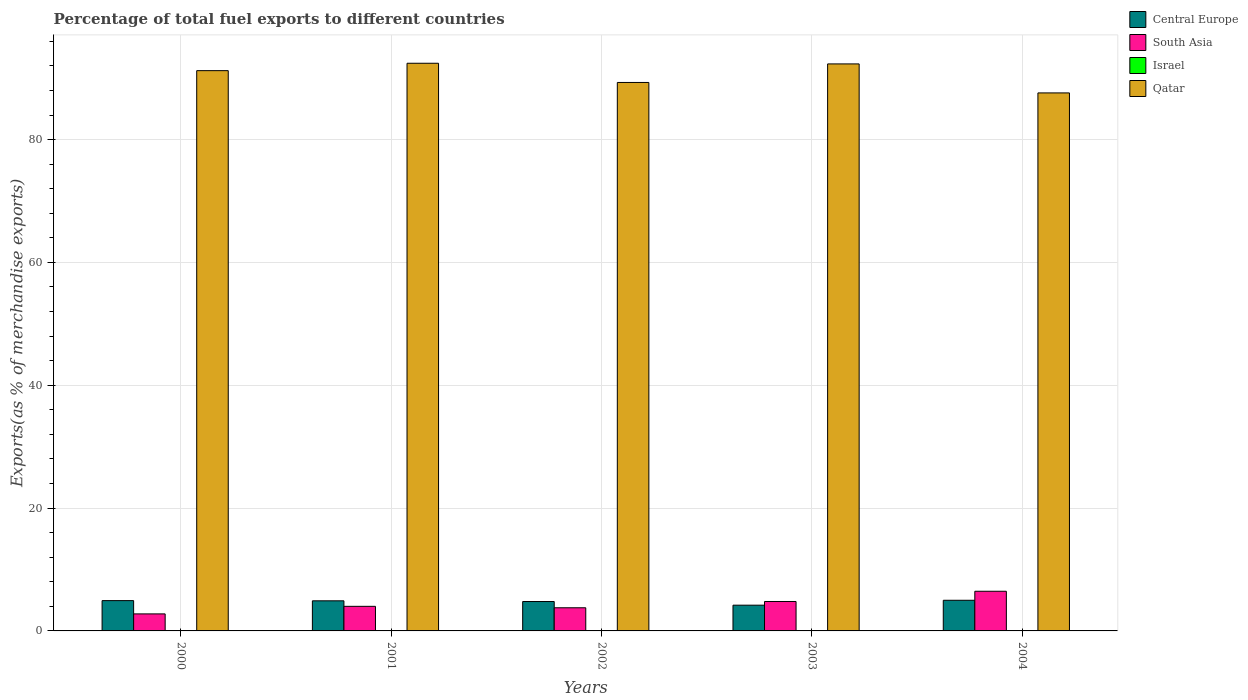How many groups of bars are there?
Your answer should be very brief. 5. How many bars are there on the 4th tick from the left?
Your answer should be very brief. 4. What is the label of the 3rd group of bars from the left?
Provide a succinct answer. 2002. What is the percentage of exports to different countries in South Asia in 2003?
Make the answer very short. 4.79. Across all years, what is the maximum percentage of exports to different countries in South Asia?
Keep it short and to the point. 6.46. Across all years, what is the minimum percentage of exports to different countries in Central Europe?
Your answer should be compact. 4.19. In which year was the percentage of exports to different countries in Qatar minimum?
Ensure brevity in your answer.  2004. What is the total percentage of exports to different countries in Central Europe in the graph?
Make the answer very short. 23.8. What is the difference between the percentage of exports to different countries in Israel in 2001 and that in 2004?
Provide a short and direct response. -0. What is the difference between the percentage of exports to different countries in South Asia in 2003 and the percentage of exports to different countries in Israel in 2002?
Provide a succinct answer. 4.75. What is the average percentage of exports to different countries in South Asia per year?
Your response must be concise. 4.36. In the year 2003, what is the difference between the percentage of exports to different countries in South Asia and percentage of exports to different countries in Central Europe?
Offer a very short reply. 0.6. What is the ratio of the percentage of exports to different countries in Central Europe in 2001 to that in 2003?
Give a very brief answer. 1.17. Is the percentage of exports to different countries in Central Europe in 2002 less than that in 2003?
Give a very brief answer. No. What is the difference between the highest and the second highest percentage of exports to different countries in South Asia?
Keep it short and to the point. 1.67. What is the difference between the highest and the lowest percentage of exports to different countries in Qatar?
Your answer should be very brief. 4.83. What does the 2nd bar from the right in 2003 represents?
Your answer should be compact. Israel. How many bars are there?
Provide a succinct answer. 20. How many years are there in the graph?
Offer a very short reply. 5. How are the legend labels stacked?
Provide a succinct answer. Vertical. What is the title of the graph?
Make the answer very short. Percentage of total fuel exports to different countries. Does "Latin America(developing only)" appear as one of the legend labels in the graph?
Offer a terse response. No. What is the label or title of the Y-axis?
Your answer should be very brief. Exports(as % of merchandise exports). What is the Exports(as % of merchandise exports) of Central Europe in 2000?
Your answer should be very brief. 4.93. What is the Exports(as % of merchandise exports) of South Asia in 2000?
Offer a very short reply. 2.77. What is the Exports(as % of merchandise exports) in Israel in 2000?
Provide a succinct answer. 0.02. What is the Exports(as % of merchandise exports) in Qatar in 2000?
Offer a very short reply. 91.23. What is the Exports(as % of merchandise exports) in Central Europe in 2001?
Give a very brief answer. 4.9. What is the Exports(as % of merchandise exports) of South Asia in 2001?
Your answer should be compact. 4. What is the Exports(as % of merchandise exports) in Israel in 2001?
Keep it short and to the point. 0.02. What is the Exports(as % of merchandise exports) of Qatar in 2001?
Give a very brief answer. 92.43. What is the Exports(as % of merchandise exports) of Central Europe in 2002?
Keep it short and to the point. 4.79. What is the Exports(as % of merchandise exports) of South Asia in 2002?
Ensure brevity in your answer.  3.77. What is the Exports(as % of merchandise exports) in Israel in 2002?
Make the answer very short. 0.04. What is the Exports(as % of merchandise exports) of Qatar in 2002?
Your response must be concise. 89.3. What is the Exports(as % of merchandise exports) of Central Europe in 2003?
Your answer should be compact. 4.19. What is the Exports(as % of merchandise exports) of South Asia in 2003?
Make the answer very short. 4.79. What is the Exports(as % of merchandise exports) in Israel in 2003?
Make the answer very short. 0.04. What is the Exports(as % of merchandise exports) of Qatar in 2003?
Your answer should be very brief. 92.32. What is the Exports(as % of merchandise exports) in Central Europe in 2004?
Your response must be concise. 4.99. What is the Exports(as % of merchandise exports) of South Asia in 2004?
Your response must be concise. 6.46. What is the Exports(as % of merchandise exports) in Israel in 2004?
Make the answer very short. 0.03. What is the Exports(as % of merchandise exports) in Qatar in 2004?
Make the answer very short. 87.6. Across all years, what is the maximum Exports(as % of merchandise exports) in Central Europe?
Your response must be concise. 4.99. Across all years, what is the maximum Exports(as % of merchandise exports) in South Asia?
Offer a terse response. 6.46. Across all years, what is the maximum Exports(as % of merchandise exports) in Israel?
Ensure brevity in your answer.  0.04. Across all years, what is the maximum Exports(as % of merchandise exports) in Qatar?
Provide a short and direct response. 92.43. Across all years, what is the minimum Exports(as % of merchandise exports) of Central Europe?
Keep it short and to the point. 4.19. Across all years, what is the minimum Exports(as % of merchandise exports) of South Asia?
Your answer should be compact. 2.77. Across all years, what is the minimum Exports(as % of merchandise exports) in Israel?
Your answer should be compact. 0.02. Across all years, what is the minimum Exports(as % of merchandise exports) of Qatar?
Provide a short and direct response. 87.6. What is the total Exports(as % of merchandise exports) of Central Europe in the graph?
Offer a very short reply. 23.8. What is the total Exports(as % of merchandise exports) in South Asia in the graph?
Your response must be concise. 21.8. What is the total Exports(as % of merchandise exports) in Israel in the graph?
Your response must be concise. 0.15. What is the total Exports(as % of merchandise exports) in Qatar in the graph?
Offer a terse response. 452.89. What is the difference between the Exports(as % of merchandise exports) of Central Europe in 2000 and that in 2001?
Keep it short and to the point. 0.03. What is the difference between the Exports(as % of merchandise exports) in South Asia in 2000 and that in 2001?
Offer a terse response. -1.23. What is the difference between the Exports(as % of merchandise exports) of Israel in 2000 and that in 2001?
Provide a succinct answer. -0. What is the difference between the Exports(as % of merchandise exports) in Qatar in 2000 and that in 2001?
Make the answer very short. -1.2. What is the difference between the Exports(as % of merchandise exports) in Central Europe in 2000 and that in 2002?
Ensure brevity in your answer.  0.15. What is the difference between the Exports(as % of merchandise exports) in South Asia in 2000 and that in 2002?
Provide a short and direct response. -1. What is the difference between the Exports(as % of merchandise exports) of Israel in 2000 and that in 2002?
Your answer should be compact. -0.02. What is the difference between the Exports(as % of merchandise exports) of Qatar in 2000 and that in 2002?
Provide a succinct answer. 1.92. What is the difference between the Exports(as % of merchandise exports) in Central Europe in 2000 and that in 2003?
Give a very brief answer. 0.74. What is the difference between the Exports(as % of merchandise exports) in South Asia in 2000 and that in 2003?
Your response must be concise. -2.02. What is the difference between the Exports(as % of merchandise exports) in Israel in 2000 and that in 2003?
Your response must be concise. -0.01. What is the difference between the Exports(as % of merchandise exports) in Qatar in 2000 and that in 2003?
Your answer should be very brief. -1.1. What is the difference between the Exports(as % of merchandise exports) in Central Europe in 2000 and that in 2004?
Offer a terse response. -0.06. What is the difference between the Exports(as % of merchandise exports) in South Asia in 2000 and that in 2004?
Keep it short and to the point. -3.69. What is the difference between the Exports(as % of merchandise exports) in Israel in 2000 and that in 2004?
Offer a very short reply. -0. What is the difference between the Exports(as % of merchandise exports) in Qatar in 2000 and that in 2004?
Give a very brief answer. 3.62. What is the difference between the Exports(as % of merchandise exports) in Central Europe in 2001 and that in 2002?
Offer a terse response. 0.12. What is the difference between the Exports(as % of merchandise exports) of South Asia in 2001 and that in 2002?
Provide a succinct answer. 0.23. What is the difference between the Exports(as % of merchandise exports) of Israel in 2001 and that in 2002?
Ensure brevity in your answer.  -0.02. What is the difference between the Exports(as % of merchandise exports) of Qatar in 2001 and that in 2002?
Offer a terse response. 3.13. What is the difference between the Exports(as % of merchandise exports) of Central Europe in 2001 and that in 2003?
Give a very brief answer. 0.71. What is the difference between the Exports(as % of merchandise exports) in South Asia in 2001 and that in 2003?
Your answer should be very brief. -0.79. What is the difference between the Exports(as % of merchandise exports) of Israel in 2001 and that in 2003?
Offer a very short reply. -0.01. What is the difference between the Exports(as % of merchandise exports) in Qatar in 2001 and that in 2003?
Offer a very short reply. 0.11. What is the difference between the Exports(as % of merchandise exports) in Central Europe in 2001 and that in 2004?
Your response must be concise. -0.09. What is the difference between the Exports(as % of merchandise exports) of South Asia in 2001 and that in 2004?
Make the answer very short. -2.45. What is the difference between the Exports(as % of merchandise exports) in Israel in 2001 and that in 2004?
Your answer should be very brief. -0. What is the difference between the Exports(as % of merchandise exports) in Qatar in 2001 and that in 2004?
Keep it short and to the point. 4.83. What is the difference between the Exports(as % of merchandise exports) in Central Europe in 2002 and that in 2003?
Offer a terse response. 0.59. What is the difference between the Exports(as % of merchandise exports) in South Asia in 2002 and that in 2003?
Provide a succinct answer. -1.02. What is the difference between the Exports(as % of merchandise exports) of Israel in 2002 and that in 2003?
Offer a terse response. 0. What is the difference between the Exports(as % of merchandise exports) of Qatar in 2002 and that in 2003?
Provide a short and direct response. -3.02. What is the difference between the Exports(as % of merchandise exports) in Central Europe in 2002 and that in 2004?
Make the answer very short. -0.21. What is the difference between the Exports(as % of merchandise exports) of South Asia in 2002 and that in 2004?
Offer a very short reply. -2.69. What is the difference between the Exports(as % of merchandise exports) of Israel in 2002 and that in 2004?
Offer a very short reply. 0.01. What is the difference between the Exports(as % of merchandise exports) of Qatar in 2002 and that in 2004?
Make the answer very short. 1.7. What is the difference between the Exports(as % of merchandise exports) in Central Europe in 2003 and that in 2004?
Offer a very short reply. -0.8. What is the difference between the Exports(as % of merchandise exports) of South Asia in 2003 and that in 2004?
Offer a terse response. -1.67. What is the difference between the Exports(as % of merchandise exports) in Israel in 2003 and that in 2004?
Offer a very short reply. 0.01. What is the difference between the Exports(as % of merchandise exports) in Qatar in 2003 and that in 2004?
Your answer should be compact. 4.72. What is the difference between the Exports(as % of merchandise exports) of Central Europe in 2000 and the Exports(as % of merchandise exports) of South Asia in 2001?
Provide a succinct answer. 0.93. What is the difference between the Exports(as % of merchandise exports) in Central Europe in 2000 and the Exports(as % of merchandise exports) in Israel in 2001?
Give a very brief answer. 4.91. What is the difference between the Exports(as % of merchandise exports) of Central Europe in 2000 and the Exports(as % of merchandise exports) of Qatar in 2001?
Your answer should be very brief. -87.5. What is the difference between the Exports(as % of merchandise exports) of South Asia in 2000 and the Exports(as % of merchandise exports) of Israel in 2001?
Provide a succinct answer. 2.75. What is the difference between the Exports(as % of merchandise exports) in South Asia in 2000 and the Exports(as % of merchandise exports) in Qatar in 2001?
Ensure brevity in your answer.  -89.66. What is the difference between the Exports(as % of merchandise exports) of Israel in 2000 and the Exports(as % of merchandise exports) of Qatar in 2001?
Keep it short and to the point. -92.41. What is the difference between the Exports(as % of merchandise exports) of Central Europe in 2000 and the Exports(as % of merchandise exports) of South Asia in 2002?
Your response must be concise. 1.16. What is the difference between the Exports(as % of merchandise exports) in Central Europe in 2000 and the Exports(as % of merchandise exports) in Israel in 2002?
Make the answer very short. 4.89. What is the difference between the Exports(as % of merchandise exports) in Central Europe in 2000 and the Exports(as % of merchandise exports) in Qatar in 2002?
Your answer should be very brief. -84.37. What is the difference between the Exports(as % of merchandise exports) in South Asia in 2000 and the Exports(as % of merchandise exports) in Israel in 2002?
Give a very brief answer. 2.73. What is the difference between the Exports(as % of merchandise exports) of South Asia in 2000 and the Exports(as % of merchandise exports) of Qatar in 2002?
Ensure brevity in your answer.  -86.53. What is the difference between the Exports(as % of merchandise exports) of Israel in 2000 and the Exports(as % of merchandise exports) of Qatar in 2002?
Ensure brevity in your answer.  -89.28. What is the difference between the Exports(as % of merchandise exports) in Central Europe in 2000 and the Exports(as % of merchandise exports) in South Asia in 2003?
Your response must be concise. 0.14. What is the difference between the Exports(as % of merchandise exports) of Central Europe in 2000 and the Exports(as % of merchandise exports) of Israel in 2003?
Offer a terse response. 4.89. What is the difference between the Exports(as % of merchandise exports) of Central Europe in 2000 and the Exports(as % of merchandise exports) of Qatar in 2003?
Your answer should be very brief. -87.39. What is the difference between the Exports(as % of merchandise exports) in South Asia in 2000 and the Exports(as % of merchandise exports) in Israel in 2003?
Offer a very short reply. 2.73. What is the difference between the Exports(as % of merchandise exports) of South Asia in 2000 and the Exports(as % of merchandise exports) of Qatar in 2003?
Offer a terse response. -89.55. What is the difference between the Exports(as % of merchandise exports) of Israel in 2000 and the Exports(as % of merchandise exports) of Qatar in 2003?
Provide a short and direct response. -92.3. What is the difference between the Exports(as % of merchandise exports) of Central Europe in 2000 and the Exports(as % of merchandise exports) of South Asia in 2004?
Ensure brevity in your answer.  -1.52. What is the difference between the Exports(as % of merchandise exports) in Central Europe in 2000 and the Exports(as % of merchandise exports) in Israel in 2004?
Keep it short and to the point. 4.91. What is the difference between the Exports(as % of merchandise exports) of Central Europe in 2000 and the Exports(as % of merchandise exports) of Qatar in 2004?
Your response must be concise. -82.67. What is the difference between the Exports(as % of merchandise exports) in South Asia in 2000 and the Exports(as % of merchandise exports) in Israel in 2004?
Your answer should be compact. 2.75. What is the difference between the Exports(as % of merchandise exports) of South Asia in 2000 and the Exports(as % of merchandise exports) of Qatar in 2004?
Ensure brevity in your answer.  -84.83. What is the difference between the Exports(as % of merchandise exports) in Israel in 2000 and the Exports(as % of merchandise exports) in Qatar in 2004?
Your answer should be compact. -87.58. What is the difference between the Exports(as % of merchandise exports) of Central Europe in 2001 and the Exports(as % of merchandise exports) of South Asia in 2002?
Offer a terse response. 1.13. What is the difference between the Exports(as % of merchandise exports) in Central Europe in 2001 and the Exports(as % of merchandise exports) in Israel in 2002?
Your response must be concise. 4.86. What is the difference between the Exports(as % of merchandise exports) in Central Europe in 2001 and the Exports(as % of merchandise exports) in Qatar in 2002?
Your response must be concise. -84.4. What is the difference between the Exports(as % of merchandise exports) of South Asia in 2001 and the Exports(as % of merchandise exports) of Israel in 2002?
Your answer should be compact. 3.96. What is the difference between the Exports(as % of merchandise exports) of South Asia in 2001 and the Exports(as % of merchandise exports) of Qatar in 2002?
Keep it short and to the point. -85.3. What is the difference between the Exports(as % of merchandise exports) of Israel in 2001 and the Exports(as % of merchandise exports) of Qatar in 2002?
Keep it short and to the point. -89.28. What is the difference between the Exports(as % of merchandise exports) of Central Europe in 2001 and the Exports(as % of merchandise exports) of South Asia in 2003?
Your response must be concise. 0.11. What is the difference between the Exports(as % of merchandise exports) of Central Europe in 2001 and the Exports(as % of merchandise exports) of Israel in 2003?
Your answer should be very brief. 4.86. What is the difference between the Exports(as % of merchandise exports) in Central Europe in 2001 and the Exports(as % of merchandise exports) in Qatar in 2003?
Your answer should be very brief. -87.42. What is the difference between the Exports(as % of merchandise exports) in South Asia in 2001 and the Exports(as % of merchandise exports) in Israel in 2003?
Your response must be concise. 3.97. What is the difference between the Exports(as % of merchandise exports) of South Asia in 2001 and the Exports(as % of merchandise exports) of Qatar in 2003?
Provide a succinct answer. -88.32. What is the difference between the Exports(as % of merchandise exports) in Israel in 2001 and the Exports(as % of merchandise exports) in Qatar in 2003?
Your answer should be compact. -92.3. What is the difference between the Exports(as % of merchandise exports) in Central Europe in 2001 and the Exports(as % of merchandise exports) in South Asia in 2004?
Give a very brief answer. -1.56. What is the difference between the Exports(as % of merchandise exports) in Central Europe in 2001 and the Exports(as % of merchandise exports) in Israel in 2004?
Your answer should be very brief. 4.87. What is the difference between the Exports(as % of merchandise exports) in Central Europe in 2001 and the Exports(as % of merchandise exports) in Qatar in 2004?
Ensure brevity in your answer.  -82.7. What is the difference between the Exports(as % of merchandise exports) of South Asia in 2001 and the Exports(as % of merchandise exports) of Israel in 2004?
Offer a terse response. 3.98. What is the difference between the Exports(as % of merchandise exports) of South Asia in 2001 and the Exports(as % of merchandise exports) of Qatar in 2004?
Provide a short and direct response. -83.6. What is the difference between the Exports(as % of merchandise exports) in Israel in 2001 and the Exports(as % of merchandise exports) in Qatar in 2004?
Ensure brevity in your answer.  -87.58. What is the difference between the Exports(as % of merchandise exports) of Central Europe in 2002 and the Exports(as % of merchandise exports) of South Asia in 2003?
Ensure brevity in your answer.  -0.01. What is the difference between the Exports(as % of merchandise exports) of Central Europe in 2002 and the Exports(as % of merchandise exports) of Israel in 2003?
Your answer should be very brief. 4.75. What is the difference between the Exports(as % of merchandise exports) of Central Europe in 2002 and the Exports(as % of merchandise exports) of Qatar in 2003?
Your response must be concise. -87.54. What is the difference between the Exports(as % of merchandise exports) of South Asia in 2002 and the Exports(as % of merchandise exports) of Israel in 2003?
Your answer should be compact. 3.73. What is the difference between the Exports(as % of merchandise exports) of South Asia in 2002 and the Exports(as % of merchandise exports) of Qatar in 2003?
Provide a succinct answer. -88.56. What is the difference between the Exports(as % of merchandise exports) in Israel in 2002 and the Exports(as % of merchandise exports) in Qatar in 2003?
Provide a short and direct response. -92.28. What is the difference between the Exports(as % of merchandise exports) of Central Europe in 2002 and the Exports(as % of merchandise exports) of South Asia in 2004?
Keep it short and to the point. -1.67. What is the difference between the Exports(as % of merchandise exports) in Central Europe in 2002 and the Exports(as % of merchandise exports) in Israel in 2004?
Offer a terse response. 4.76. What is the difference between the Exports(as % of merchandise exports) in Central Europe in 2002 and the Exports(as % of merchandise exports) in Qatar in 2004?
Offer a terse response. -82.82. What is the difference between the Exports(as % of merchandise exports) of South Asia in 2002 and the Exports(as % of merchandise exports) of Israel in 2004?
Provide a succinct answer. 3.74. What is the difference between the Exports(as % of merchandise exports) in South Asia in 2002 and the Exports(as % of merchandise exports) in Qatar in 2004?
Your response must be concise. -83.83. What is the difference between the Exports(as % of merchandise exports) in Israel in 2002 and the Exports(as % of merchandise exports) in Qatar in 2004?
Your answer should be compact. -87.56. What is the difference between the Exports(as % of merchandise exports) in Central Europe in 2003 and the Exports(as % of merchandise exports) in South Asia in 2004?
Offer a very short reply. -2.27. What is the difference between the Exports(as % of merchandise exports) in Central Europe in 2003 and the Exports(as % of merchandise exports) in Israel in 2004?
Your response must be concise. 4.16. What is the difference between the Exports(as % of merchandise exports) of Central Europe in 2003 and the Exports(as % of merchandise exports) of Qatar in 2004?
Provide a short and direct response. -83.41. What is the difference between the Exports(as % of merchandise exports) in South Asia in 2003 and the Exports(as % of merchandise exports) in Israel in 2004?
Your answer should be very brief. 4.76. What is the difference between the Exports(as % of merchandise exports) of South Asia in 2003 and the Exports(as % of merchandise exports) of Qatar in 2004?
Provide a short and direct response. -82.81. What is the difference between the Exports(as % of merchandise exports) in Israel in 2003 and the Exports(as % of merchandise exports) in Qatar in 2004?
Provide a succinct answer. -87.56. What is the average Exports(as % of merchandise exports) of Central Europe per year?
Give a very brief answer. 4.76. What is the average Exports(as % of merchandise exports) in South Asia per year?
Provide a short and direct response. 4.36. What is the average Exports(as % of merchandise exports) of Israel per year?
Give a very brief answer. 0.03. What is the average Exports(as % of merchandise exports) of Qatar per year?
Offer a very short reply. 90.58. In the year 2000, what is the difference between the Exports(as % of merchandise exports) in Central Europe and Exports(as % of merchandise exports) in South Asia?
Your answer should be very brief. 2.16. In the year 2000, what is the difference between the Exports(as % of merchandise exports) of Central Europe and Exports(as % of merchandise exports) of Israel?
Ensure brevity in your answer.  4.91. In the year 2000, what is the difference between the Exports(as % of merchandise exports) of Central Europe and Exports(as % of merchandise exports) of Qatar?
Make the answer very short. -86.29. In the year 2000, what is the difference between the Exports(as % of merchandise exports) in South Asia and Exports(as % of merchandise exports) in Israel?
Offer a terse response. 2.75. In the year 2000, what is the difference between the Exports(as % of merchandise exports) in South Asia and Exports(as % of merchandise exports) in Qatar?
Ensure brevity in your answer.  -88.45. In the year 2000, what is the difference between the Exports(as % of merchandise exports) in Israel and Exports(as % of merchandise exports) in Qatar?
Provide a succinct answer. -91.2. In the year 2001, what is the difference between the Exports(as % of merchandise exports) of Central Europe and Exports(as % of merchandise exports) of South Asia?
Offer a terse response. 0.9. In the year 2001, what is the difference between the Exports(as % of merchandise exports) in Central Europe and Exports(as % of merchandise exports) in Israel?
Your answer should be compact. 4.88. In the year 2001, what is the difference between the Exports(as % of merchandise exports) in Central Europe and Exports(as % of merchandise exports) in Qatar?
Offer a very short reply. -87.53. In the year 2001, what is the difference between the Exports(as % of merchandise exports) of South Asia and Exports(as % of merchandise exports) of Israel?
Make the answer very short. 3.98. In the year 2001, what is the difference between the Exports(as % of merchandise exports) in South Asia and Exports(as % of merchandise exports) in Qatar?
Ensure brevity in your answer.  -88.43. In the year 2001, what is the difference between the Exports(as % of merchandise exports) in Israel and Exports(as % of merchandise exports) in Qatar?
Your answer should be compact. -92.41. In the year 2002, what is the difference between the Exports(as % of merchandise exports) of Central Europe and Exports(as % of merchandise exports) of South Asia?
Offer a very short reply. 1.02. In the year 2002, what is the difference between the Exports(as % of merchandise exports) of Central Europe and Exports(as % of merchandise exports) of Israel?
Your answer should be compact. 4.75. In the year 2002, what is the difference between the Exports(as % of merchandise exports) in Central Europe and Exports(as % of merchandise exports) in Qatar?
Your response must be concise. -84.52. In the year 2002, what is the difference between the Exports(as % of merchandise exports) in South Asia and Exports(as % of merchandise exports) in Israel?
Your answer should be very brief. 3.73. In the year 2002, what is the difference between the Exports(as % of merchandise exports) of South Asia and Exports(as % of merchandise exports) of Qatar?
Keep it short and to the point. -85.54. In the year 2002, what is the difference between the Exports(as % of merchandise exports) of Israel and Exports(as % of merchandise exports) of Qatar?
Provide a short and direct response. -89.26. In the year 2003, what is the difference between the Exports(as % of merchandise exports) of Central Europe and Exports(as % of merchandise exports) of South Asia?
Your answer should be compact. -0.6. In the year 2003, what is the difference between the Exports(as % of merchandise exports) in Central Europe and Exports(as % of merchandise exports) in Israel?
Give a very brief answer. 4.15. In the year 2003, what is the difference between the Exports(as % of merchandise exports) in Central Europe and Exports(as % of merchandise exports) in Qatar?
Keep it short and to the point. -88.13. In the year 2003, what is the difference between the Exports(as % of merchandise exports) in South Asia and Exports(as % of merchandise exports) in Israel?
Provide a short and direct response. 4.75. In the year 2003, what is the difference between the Exports(as % of merchandise exports) of South Asia and Exports(as % of merchandise exports) of Qatar?
Your answer should be compact. -87.53. In the year 2003, what is the difference between the Exports(as % of merchandise exports) of Israel and Exports(as % of merchandise exports) of Qatar?
Offer a terse response. -92.29. In the year 2004, what is the difference between the Exports(as % of merchandise exports) in Central Europe and Exports(as % of merchandise exports) in South Asia?
Ensure brevity in your answer.  -1.47. In the year 2004, what is the difference between the Exports(as % of merchandise exports) in Central Europe and Exports(as % of merchandise exports) in Israel?
Make the answer very short. 4.96. In the year 2004, what is the difference between the Exports(as % of merchandise exports) in Central Europe and Exports(as % of merchandise exports) in Qatar?
Keep it short and to the point. -82.61. In the year 2004, what is the difference between the Exports(as % of merchandise exports) in South Asia and Exports(as % of merchandise exports) in Israel?
Offer a very short reply. 6.43. In the year 2004, what is the difference between the Exports(as % of merchandise exports) in South Asia and Exports(as % of merchandise exports) in Qatar?
Provide a succinct answer. -81.15. In the year 2004, what is the difference between the Exports(as % of merchandise exports) of Israel and Exports(as % of merchandise exports) of Qatar?
Give a very brief answer. -87.58. What is the ratio of the Exports(as % of merchandise exports) in South Asia in 2000 to that in 2001?
Keep it short and to the point. 0.69. What is the ratio of the Exports(as % of merchandise exports) of Israel in 2000 to that in 2001?
Keep it short and to the point. 0.98. What is the ratio of the Exports(as % of merchandise exports) in Qatar in 2000 to that in 2001?
Keep it short and to the point. 0.99. What is the ratio of the Exports(as % of merchandise exports) in Central Europe in 2000 to that in 2002?
Make the answer very short. 1.03. What is the ratio of the Exports(as % of merchandise exports) of South Asia in 2000 to that in 2002?
Ensure brevity in your answer.  0.74. What is the ratio of the Exports(as % of merchandise exports) of Israel in 2000 to that in 2002?
Your response must be concise. 0.6. What is the ratio of the Exports(as % of merchandise exports) in Qatar in 2000 to that in 2002?
Offer a terse response. 1.02. What is the ratio of the Exports(as % of merchandise exports) of Central Europe in 2000 to that in 2003?
Your response must be concise. 1.18. What is the ratio of the Exports(as % of merchandise exports) in South Asia in 2000 to that in 2003?
Give a very brief answer. 0.58. What is the ratio of the Exports(as % of merchandise exports) of Israel in 2000 to that in 2003?
Your response must be concise. 0.63. What is the ratio of the Exports(as % of merchandise exports) of Central Europe in 2000 to that in 2004?
Your answer should be very brief. 0.99. What is the ratio of the Exports(as % of merchandise exports) in South Asia in 2000 to that in 2004?
Keep it short and to the point. 0.43. What is the ratio of the Exports(as % of merchandise exports) in Israel in 2000 to that in 2004?
Give a very brief answer. 0.87. What is the ratio of the Exports(as % of merchandise exports) in Qatar in 2000 to that in 2004?
Your answer should be compact. 1.04. What is the ratio of the Exports(as % of merchandise exports) of Central Europe in 2001 to that in 2002?
Your answer should be very brief. 1.02. What is the ratio of the Exports(as % of merchandise exports) in South Asia in 2001 to that in 2002?
Your answer should be very brief. 1.06. What is the ratio of the Exports(as % of merchandise exports) of Israel in 2001 to that in 2002?
Your answer should be very brief. 0.61. What is the ratio of the Exports(as % of merchandise exports) of Qatar in 2001 to that in 2002?
Ensure brevity in your answer.  1.03. What is the ratio of the Exports(as % of merchandise exports) of Central Europe in 2001 to that in 2003?
Give a very brief answer. 1.17. What is the ratio of the Exports(as % of merchandise exports) of South Asia in 2001 to that in 2003?
Ensure brevity in your answer.  0.84. What is the ratio of the Exports(as % of merchandise exports) in Israel in 2001 to that in 2003?
Offer a terse response. 0.64. What is the ratio of the Exports(as % of merchandise exports) in Central Europe in 2001 to that in 2004?
Ensure brevity in your answer.  0.98. What is the ratio of the Exports(as % of merchandise exports) of South Asia in 2001 to that in 2004?
Your answer should be very brief. 0.62. What is the ratio of the Exports(as % of merchandise exports) of Israel in 2001 to that in 2004?
Your answer should be very brief. 0.89. What is the ratio of the Exports(as % of merchandise exports) in Qatar in 2001 to that in 2004?
Ensure brevity in your answer.  1.06. What is the ratio of the Exports(as % of merchandise exports) of Central Europe in 2002 to that in 2003?
Your answer should be very brief. 1.14. What is the ratio of the Exports(as % of merchandise exports) in South Asia in 2002 to that in 2003?
Keep it short and to the point. 0.79. What is the ratio of the Exports(as % of merchandise exports) of Israel in 2002 to that in 2003?
Your answer should be compact. 1.05. What is the ratio of the Exports(as % of merchandise exports) of Qatar in 2002 to that in 2003?
Ensure brevity in your answer.  0.97. What is the ratio of the Exports(as % of merchandise exports) of Central Europe in 2002 to that in 2004?
Provide a short and direct response. 0.96. What is the ratio of the Exports(as % of merchandise exports) of South Asia in 2002 to that in 2004?
Your answer should be compact. 0.58. What is the ratio of the Exports(as % of merchandise exports) in Israel in 2002 to that in 2004?
Ensure brevity in your answer.  1.47. What is the ratio of the Exports(as % of merchandise exports) of Qatar in 2002 to that in 2004?
Offer a terse response. 1.02. What is the ratio of the Exports(as % of merchandise exports) of Central Europe in 2003 to that in 2004?
Provide a short and direct response. 0.84. What is the ratio of the Exports(as % of merchandise exports) in South Asia in 2003 to that in 2004?
Keep it short and to the point. 0.74. What is the ratio of the Exports(as % of merchandise exports) in Israel in 2003 to that in 2004?
Ensure brevity in your answer.  1.4. What is the ratio of the Exports(as % of merchandise exports) of Qatar in 2003 to that in 2004?
Offer a very short reply. 1.05. What is the difference between the highest and the second highest Exports(as % of merchandise exports) in Central Europe?
Your answer should be very brief. 0.06. What is the difference between the highest and the second highest Exports(as % of merchandise exports) in South Asia?
Give a very brief answer. 1.67. What is the difference between the highest and the second highest Exports(as % of merchandise exports) of Israel?
Make the answer very short. 0. What is the difference between the highest and the second highest Exports(as % of merchandise exports) of Qatar?
Ensure brevity in your answer.  0.11. What is the difference between the highest and the lowest Exports(as % of merchandise exports) in Central Europe?
Give a very brief answer. 0.8. What is the difference between the highest and the lowest Exports(as % of merchandise exports) of South Asia?
Offer a very short reply. 3.69. What is the difference between the highest and the lowest Exports(as % of merchandise exports) in Israel?
Offer a terse response. 0.02. What is the difference between the highest and the lowest Exports(as % of merchandise exports) in Qatar?
Your response must be concise. 4.83. 